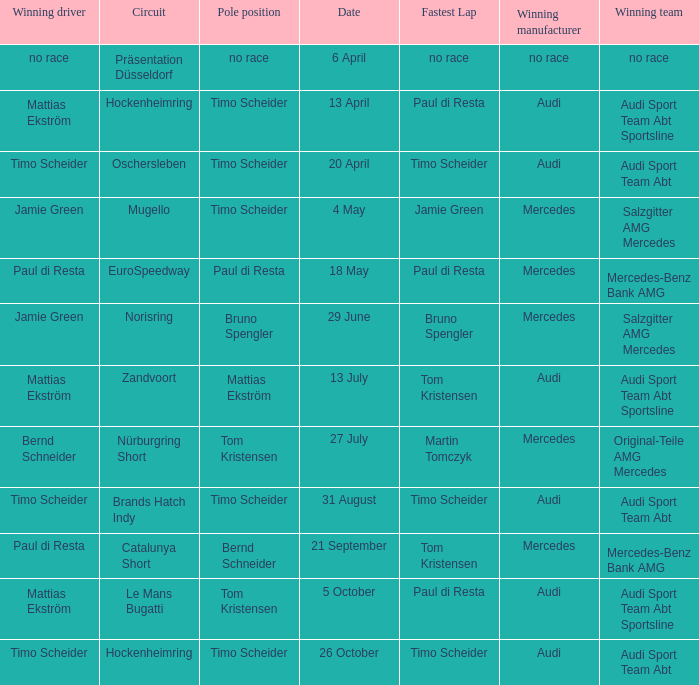What is the fastest lap of the Oschersleben circuit with Audi Sport Team ABT as the winning team? Timo Scheider. 